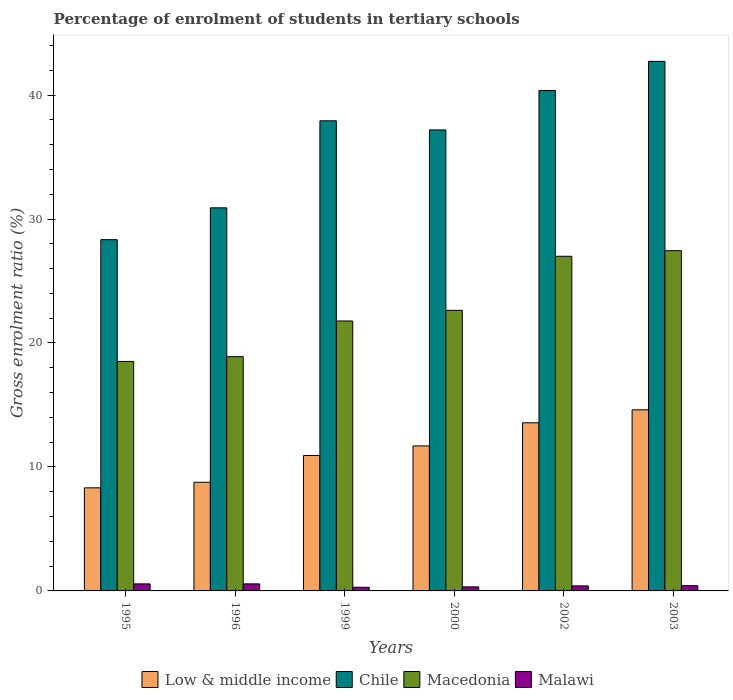Are the number of bars per tick equal to the number of legend labels?
Offer a terse response. Yes. Are the number of bars on each tick of the X-axis equal?
Your answer should be compact. Yes. How many bars are there on the 6th tick from the left?
Keep it short and to the point. 4. What is the label of the 1st group of bars from the left?
Keep it short and to the point. 1995. In how many cases, is the number of bars for a given year not equal to the number of legend labels?
Provide a short and direct response. 0. What is the percentage of students enrolled in tertiary schools in Macedonia in 1995?
Offer a very short reply. 18.51. Across all years, what is the maximum percentage of students enrolled in tertiary schools in Macedonia?
Your response must be concise. 27.44. Across all years, what is the minimum percentage of students enrolled in tertiary schools in Chile?
Offer a terse response. 28.33. In which year was the percentage of students enrolled in tertiary schools in Malawi maximum?
Keep it short and to the point. 1996. What is the total percentage of students enrolled in tertiary schools in Low & middle income in the graph?
Your answer should be compact. 67.87. What is the difference between the percentage of students enrolled in tertiary schools in Macedonia in 2000 and that in 2003?
Give a very brief answer. -4.81. What is the difference between the percentage of students enrolled in tertiary schools in Macedonia in 2003 and the percentage of students enrolled in tertiary schools in Malawi in 1995?
Keep it short and to the point. 26.88. What is the average percentage of students enrolled in tertiary schools in Macedonia per year?
Your response must be concise. 22.71. In the year 2003, what is the difference between the percentage of students enrolled in tertiary schools in Macedonia and percentage of students enrolled in tertiary schools in Malawi?
Your answer should be very brief. 27.02. What is the ratio of the percentage of students enrolled in tertiary schools in Malawi in 1999 to that in 2002?
Ensure brevity in your answer.  0.73. Is the percentage of students enrolled in tertiary schools in Chile in 1996 less than that in 2003?
Ensure brevity in your answer.  Yes. What is the difference between the highest and the second highest percentage of students enrolled in tertiary schools in Macedonia?
Provide a succinct answer. 0.45. What is the difference between the highest and the lowest percentage of students enrolled in tertiary schools in Chile?
Provide a succinct answer. 14.38. Is the sum of the percentage of students enrolled in tertiary schools in Macedonia in 1995 and 2003 greater than the maximum percentage of students enrolled in tertiary schools in Chile across all years?
Your response must be concise. Yes. What does the 3rd bar from the right in 1996 represents?
Your response must be concise. Chile. How many bars are there?
Offer a terse response. 24. How many years are there in the graph?
Make the answer very short. 6. What is the difference between two consecutive major ticks on the Y-axis?
Keep it short and to the point. 10. Does the graph contain any zero values?
Keep it short and to the point. No. How many legend labels are there?
Keep it short and to the point. 4. What is the title of the graph?
Your response must be concise. Percentage of enrolment of students in tertiary schools. What is the label or title of the X-axis?
Provide a short and direct response. Years. What is the label or title of the Y-axis?
Provide a short and direct response. Gross enrolment ratio (%). What is the Gross enrolment ratio (%) in Low & middle income in 1995?
Ensure brevity in your answer.  8.32. What is the Gross enrolment ratio (%) of Chile in 1995?
Your answer should be very brief. 28.33. What is the Gross enrolment ratio (%) in Macedonia in 1995?
Make the answer very short. 18.51. What is the Gross enrolment ratio (%) in Malawi in 1995?
Keep it short and to the point. 0.57. What is the Gross enrolment ratio (%) of Low & middle income in 1996?
Make the answer very short. 8.76. What is the Gross enrolment ratio (%) of Chile in 1996?
Your answer should be compact. 30.9. What is the Gross enrolment ratio (%) of Macedonia in 1996?
Ensure brevity in your answer.  18.9. What is the Gross enrolment ratio (%) of Malawi in 1996?
Your answer should be compact. 0.57. What is the Gross enrolment ratio (%) of Low & middle income in 1999?
Offer a terse response. 10.92. What is the Gross enrolment ratio (%) of Chile in 1999?
Offer a terse response. 37.92. What is the Gross enrolment ratio (%) of Macedonia in 1999?
Provide a short and direct response. 21.77. What is the Gross enrolment ratio (%) in Malawi in 1999?
Provide a succinct answer. 0.3. What is the Gross enrolment ratio (%) of Low & middle income in 2000?
Give a very brief answer. 11.7. What is the Gross enrolment ratio (%) of Chile in 2000?
Your answer should be very brief. 37.19. What is the Gross enrolment ratio (%) of Macedonia in 2000?
Your answer should be compact. 22.63. What is the Gross enrolment ratio (%) in Malawi in 2000?
Offer a terse response. 0.33. What is the Gross enrolment ratio (%) in Low & middle income in 2002?
Ensure brevity in your answer.  13.56. What is the Gross enrolment ratio (%) in Chile in 2002?
Ensure brevity in your answer.  40.37. What is the Gross enrolment ratio (%) in Macedonia in 2002?
Your answer should be compact. 26.99. What is the Gross enrolment ratio (%) in Malawi in 2002?
Your answer should be very brief. 0.41. What is the Gross enrolment ratio (%) in Low & middle income in 2003?
Keep it short and to the point. 14.61. What is the Gross enrolment ratio (%) in Chile in 2003?
Your response must be concise. 42.72. What is the Gross enrolment ratio (%) of Macedonia in 2003?
Provide a short and direct response. 27.44. What is the Gross enrolment ratio (%) in Malawi in 2003?
Keep it short and to the point. 0.42. Across all years, what is the maximum Gross enrolment ratio (%) in Low & middle income?
Offer a terse response. 14.61. Across all years, what is the maximum Gross enrolment ratio (%) in Chile?
Your response must be concise. 42.72. Across all years, what is the maximum Gross enrolment ratio (%) of Macedonia?
Your answer should be very brief. 27.44. Across all years, what is the maximum Gross enrolment ratio (%) of Malawi?
Your answer should be very brief. 0.57. Across all years, what is the minimum Gross enrolment ratio (%) in Low & middle income?
Make the answer very short. 8.32. Across all years, what is the minimum Gross enrolment ratio (%) of Chile?
Provide a short and direct response. 28.33. Across all years, what is the minimum Gross enrolment ratio (%) in Macedonia?
Ensure brevity in your answer.  18.51. Across all years, what is the minimum Gross enrolment ratio (%) in Malawi?
Your answer should be very brief. 0.3. What is the total Gross enrolment ratio (%) in Low & middle income in the graph?
Offer a very short reply. 67.87. What is the total Gross enrolment ratio (%) in Chile in the graph?
Provide a succinct answer. 217.43. What is the total Gross enrolment ratio (%) in Macedonia in the graph?
Your answer should be very brief. 136.25. What is the total Gross enrolment ratio (%) of Malawi in the graph?
Your answer should be very brief. 2.59. What is the difference between the Gross enrolment ratio (%) of Low & middle income in 1995 and that in 1996?
Offer a terse response. -0.45. What is the difference between the Gross enrolment ratio (%) of Chile in 1995 and that in 1996?
Provide a short and direct response. -2.57. What is the difference between the Gross enrolment ratio (%) in Macedonia in 1995 and that in 1996?
Provide a succinct answer. -0.39. What is the difference between the Gross enrolment ratio (%) of Malawi in 1995 and that in 1996?
Make the answer very short. -0. What is the difference between the Gross enrolment ratio (%) in Low & middle income in 1995 and that in 1999?
Ensure brevity in your answer.  -2.61. What is the difference between the Gross enrolment ratio (%) in Chile in 1995 and that in 1999?
Your response must be concise. -9.59. What is the difference between the Gross enrolment ratio (%) of Macedonia in 1995 and that in 1999?
Give a very brief answer. -3.26. What is the difference between the Gross enrolment ratio (%) of Malawi in 1995 and that in 1999?
Offer a terse response. 0.27. What is the difference between the Gross enrolment ratio (%) of Low & middle income in 1995 and that in 2000?
Your answer should be very brief. -3.38. What is the difference between the Gross enrolment ratio (%) of Chile in 1995 and that in 2000?
Ensure brevity in your answer.  -8.85. What is the difference between the Gross enrolment ratio (%) in Macedonia in 1995 and that in 2000?
Offer a terse response. -4.12. What is the difference between the Gross enrolment ratio (%) in Malawi in 1995 and that in 2000?
Give a very brief answer. 0.24. What is the difference between the Gross enrolment ratio (%) of Low & middle income in 1995 and that in 2002?
Offer a very short reply. -5.25. What is the difference between the Gross enrolment ratio (%) of Chile in 1995 and that in 2002?
Your response must be concise. -12.03. What is the difference between the Gross enrolment ratio (%) of Macedonia in 1995 and that in 2002?
Ensure brevity in your answer.  -8.48. What is the difference between the Gross enrolment ratio (%) of Malawi in 1995 and that in 2002?
Offer a very short reply. 0.16. What is the difference between the Gross enrolment ratio (%) in Low & middle income in 1995 and that in 2003?
Make the answer very short. -6.29. What is the difference between the Gross enrolment ratio (%) of Chile in 1995 and that in 2003?
Your answer should be very brief. -14.38. What is the difference between the Gross enrolment ratio (%) in Macedonia in 1995 and that in 2003?
Offer a terse response. -8.93. What is the difference between the Gross enrolment ratio (%) of Malawi in 1995 and that in 2003?
Offer a terse response. 0.14. What is the difference between the Gross enrolment ratio (%) of Low & middle income in 1996 and that in 1999?
Your answer should be very brief. -2.16. What is the difference between the Gross enrolment ratio (%) of Chile in 1996 and that in 1999?
Offer a terse response. -7.02. What is the difference between the Gross enrolment ratio (%) of Macedonia in 1996 and that in 1999?
Ensure brevity in your answer.  -2.88. What is the difference between the Gross enrolment ratio (%) in Malawi in 1996 and that in 1999?
Make the answer very short. 0.27. What is the difference between the Gross enrolment ratio (%) of Low & middle income in 1996 and that in 2000?
Your answer should be compact. -2.93. What is the difference between the Gross enrolment ratio (%) of Chile in 1996 and that in 2000?
Offer a terse response. -6.28. What is the difference between the Gross enrolment ratio (%) of Macedonia in 1996 and that in 2000?
Your answer should be very brief. -3.74. What is the difference between the Gross enrolment ratio (%) in Malawi in 1996 and that in 2000?
Provide a succinct answer. 0.24. What is the difference between the Gross enrolment ratio (%) of Low & middle income in 1996 and that in 2002?
Provide a short and direct response. -4.8. What is the difference between the Gross enrolment ratio (%) of Chile in 1996 and that in 2002?
Make the answer very short. -9.46. What is the difference between the Gross enrolment ratio (%) of Macedonia in 1996 and that in 2002?
Keep it short and to the point. -8.1. What is the difference between the Gross enrolment ratio (%) of Malawi in 1996 and that in 2002?
Give a very brief answer. 0.16. What is the difference between the Gross enrolment ratio (%) of Low & middle income in 1996 and that in 2003?
Your answer should be very brief. -5.84. What is the difference between the Gross enrolment ratio (%) in Chile in 1996 and that in 2003?
Ensure brevity in your answer.  -11.81. What is the difference between the Gross enrolment ratio (%) of Macedonia in 1996 and that in 2003?
Provide a succinct answer. -8.55. What is the difference between the Gross enrolment ratio (%) in Malawi in 1996 and that in 2003?
Give a very brief answer. 0.15. What is the difference between the Gross enrolment ratio (%) in Low & middle income in 1999 and that in 2000?
Make the answer very short. -0.77. What is the difference between the Gross enrolment ratio (%) of Chile in 1999 and that in 2000?
Provide a succinct answer. 0.74. What is the difference between the Gross enrolment ratio (%) of Macedonia in 1999 and that in 2000?
Your answer should be compact. -0.86. What is the difference between the Gross enrolment ratio (%) in Malawi in 1999 and that in 2000?
Your answer should be compact. -0.03. What is the difference between the Gross enrolment ratio (%) of Low & middle income in 1999 and that in 2002?
Make the answer very short. -2.64. What is the difference between the Gross enrolment ratio (%) of Chile in 1999 and that in 2002?
Ensure brevity in your answer.  -2.44. What is the difference between the Gross enrolment ratio (%) in Macedonia in 1999 and that in 2002?
Provide a short and direct response. -5.22. What is the difference between the Gross enrolment ratio (%) of Malawi in 1999 and that in 2002?
Give a very brief answer. -0.11. What is the difference between the Gross enrolment ratio (%) in Low & middle income in 1999 and that in 2003?
Keep it short and to the point. -3.68. What is the difference between the Gross enrolment ratio (%) in Chile in 1999 and that in 2003?
Offer a very short reply. -4.8. What is the difference between the Gross enrolment ratio (%) in Macedonia in 1999 and that in 2003?
Give a very brief answer. -5.67. What is the difference between the Gross enrolment ratio (%) in Malawi in 1999 and that in 2003?
Provide a short and direct response. -0.13. What is the difference between the Gross enrolment ratio (%) of Low & middle income in 2000 and that in 2002?
Your answer should be very brief. -1.87. What is the difference between the Gross enrolment ratio (%) in Chile in 2000 and that in 2002?
Provide a succinct answer. -3.18. What is the difference between the Gross enrolment ratio (%) of Macedonia in 2000 and that in 2002?
Keep it short and to the point. -4.36. What is the difference between the Gross enrolment ratio (%) of Malawi in 2000 and that in 2002?
Give a very brief answer. -0.08. What is the difference between the Gross enrolment ratio (%) in Low & middle income in 2000 and that in 2003?
Your answer should be compact. -2.91. What is the difference between the Gross enrolment ratio (%) of Chile in 2000 and that in 2003?
Ensure brevity in your answer.  -5.53. What is the difference between the Gross enrolment ratio (%) of Macedonia in 2000 and that in 2003?
Make the answer very short. -4.81. What is the difference between the Gross enrolment ratio (%) in Malawi in 2000 and that in 2003?
Your answer should be very brief. -0.1. What is the difference between the Gross enrolment ratio (%) of Low & middle income in 2002 and that in 2003?
Your response must be concise. -1.04. What is the difference between the Gross enrolment ratio (%) of Chile in 2002 and that in 2003?
Keep it short and to the point. -2.35. What is the difference between the Gross enrolment ratio (%) of Macedonia in 2002 and that in 2003?
Your response must be concise. -0.45. What is the difference between the Gross enrolment ratio (%) of Malawi in 2002 and that in 2003?
Ensure brevity in your answer.  -0.02. What is the difference between the Gross enrolment ratio (%) of Low & middle income in 1995 and the Gross enrolment ratio (%) of Chile in 1996?
Offer a terse response. -22.59. What is the difference between the Gross enrolment ratio (%) in Low & middle income in 1995 and the Gross enrolment ratio (%) in Macedonia in 1996?
Provide a succinct answer. -10.58. What is the difference between the Gross enrolment ratio (%) in Low & middle income in 1995 and the Gross enrolment ratio (%) in Malawi in 1996?
Provide a succinct answer. 7.75. What is the difference between the Gross enrolment ratio (%) in Chile in 1995 and the Gross enrolment ratio (%) in Macedonia in 1996?
Your answer should be very brief. 9.44. What is the difference between the Gross enrolment ratio (%) of Chile in 1995 and the Gross enrolment ratio (%) of Malawi in 1996?
Your response must be concise. 27.77. What is the difference between the Gross enrolment ratio (%) of Macedonia in 1995 and the Gross enrolment ratio (%) of Malawi in 1996?
Provide a succinct answer. 17.94. What is the difference between the Gross enrolment ratio (%) of Low & middle income in 1995 and the Gross enrolment ratio (%) of Chile in 1999?
Give a very brief answer. -29.61. What is the difference between the Gross enrolment ratio (%) of Low & middle income in 1995 and the Gross enrolment ratio (%) of Macedonia in 1999?
Ensure brevity in your answer.  -13.46. What is the difference between the Gross enrolment ratio (%) of Low & middle income in 1995 and the Gross enrolment ratio (%) of Malawi in 1999?
Ensure brevity in your answer.  8.02. What is the difference between the Gross enrolment ratio (%) in Chile in 1995 and the Gross enrolment ratio (%) in Macedonia in 1999?
Offer a terse response. 6.56. What is the difference between the Gross enrolment ratio (%) in Chile in 1995 and the Gross enrolment ratio (%) in Malawi in 1999?
Give a very brief answer. 28.04. What is the difference between the Gross enrolment ratio (%) of Macedonia in 1995 and the Gross enrolment ratio (%) of Malawi in 1999?
Provide a short and direct response. 18.21. What is the difference between the Gross enrolment ratio (%) of Low & middle income in 1995 and the Gross enrolment ratio (%) of Chile in 2000?
Offer a very short reply. -28.87. What is the difference between the Gross enrolment ratio (%) in Low & middle income in 1995 and the Gross enrolment ratio (%) in Macedonia in 2000?
Your response must be concise. -14.32. What is the difference between the Gross enrolment ratio (%) of Low & middle income in 1995 and the Gross enrolment ratio (%) of Malawi in 2000?
Make the answer very short. 7.99. What is the difference between the Gross enrolment ratio (%) of Chile in 1995 and the Gross enrolment ratio (%) of Macedonia in 2000?
Offer a terse response. 5.7. What is the difference between the Gross enrolment ratio (%) of Chile in 1995 and the Gross enrolment ratio (%) of Malawi in 2000?
Offer a terse response. 28.01. What is the difference between the Gross enrolment ratio (%) in Macedonia in 1995 and the Gross enrolment ratio (%) in Malawi in 2000?
Provide a succinct answer. 18.18. What is the difference between the Gross enrolment ratio (%) of Low & middle income in 1995 and the Gross enrolment ratio (%) of Chile in 2002?
Provide a short and direct response. -32.05. What is the difference between the Gross enrolment ratio (%) of Low & middle income in 1995 and the Gross enrolment ratio (%) of Macedonia in 2002?
Give a very brief answer. -18.68. What is the difference between the Gross enrolment ratio (%) of Low & middle income in 1995 and the Gross enrolment ratio (%) of Malawi in 2002?
Your answer should be compact. 7.91. What is the difference between the Gross enrolment ratio (%) of Chile in 1995 and the Gross enrolment ratio (%) of Macedonia in 2002?
Ensure brevity in your answer.  1.34. What is the difference between the Gross enrolment ratio (%) of Chile in 1995 and the Gross enrolment ratio (%) of Malawi in 2002?
Ensure brevity in your answer.  27.93. What is the difference between the Gross enrolment ratio (%) of Macedonia in 1995 and the Gross enrolment ratio (%) of Malawi in 2002?
Your answer should be very brief. 18.1. What is the difference between the Gross enrolment ratio (%) of Low & middle income in 1995 and the Gross enrolment ratio (%) of Chile in 2003?
Your answer should be very brief. -34.4. What is the difference between the Gross enrolment ratio (%) of Low & middle income in 1995 and the Gross enrolment ratio (%) of Macedonia in 2003?
Provide a short and direct response. -19.13. What is the difference between the Gross enrolment ratio (%) of Low & middle income in 1995 and the Gross enrolment ratio (%) of Malawi in 2003?
Keep it short and to the point. 7.89. What is the difference between the Gross enrolment ratio (%) in Chile in 1995 and the Gross enrolment ratio (%) in Macedonia in 2003?
Give a very brief answer. 0.89. What is the difference between the Gross enrolment ratio (%) in Chile in 1995 and the Gross enrolment ratio (%) in Malawi in 2003?
Offer a very short reply. 27.91. What is the difference between the Gross enrolment ratio (%) of Macedonia in 1995 and the Gross enrolment ratio (%) of Malawi in 2003?
Your answer should be very brief. 18.09. What is the difference between the Gross enrolment ratio (%) of Low & middle income in 1996 and the Gross enrolment ratio (%) of Chile in 1999?
Provide a succinct answer. -29.16. What is the difference between the Gross enrolment ratio (%) of Low & middle income in 1996 and the Gross enrolment ratio (%) of Macedonia in 1999?
Offer a very short reply. -13.01. What is the difference between the Gross enrolment ratio (%) in Low & middle income in 1996 and the Gross enrolment ratio (%) in Malawi in 1999?
Your answer should be very brief. 8.47. What is the difference between the Gross enrolment ratio (%) of Chile in 1996 and the Gross enrolment ratio (%) of Macedonia in 1999?
Make the answer very short. 9.13. What is the difference between the Gross enrolment ratio (%) of Chile in 1996 and the Gross enrolment ratio (%) of Malawi in 1999?
Offer a very short reply. 30.61. What is the difference between the Gross enrolment ratio (%) in Macedonia in 1996 and the Gross enrolment ratio (%) in Malawi in 1999?
Provide a short and direct response. 18.6. What is the difference between the Gross enrolment ratio (%) in Low & middle income in 1996 and the Gross enrolment ratio (%) in Chile in 2000?
Offer a very short reply. -28.42. What is the difference between the Gross enrolment ratio (%) in Low & middle income in 1996 and the Gross enrolment ratio (%) in Macedonia in 2000?
Provide a short and direct response. -13.87. What is the difference between the Gross enrolment ratio (%) of Low & middle income in 1996 and the Gross enrolment ratio (%) of Malawi in 2000?
Keep it short and to the point. 8.44. What is the difference between the Gross enrolment ratio (%) of Chile in 1996 and the Gross enrolment ratio (%) of Macedonia in 2000?
Make the answer very short. 8.27. What is the difference between the Gross enrolment ratio (%) of Chile in 1996 and the Gross enrolment ratio (%) of Malawi in 2000?
Your response must be concise. 30.58. What is the difference between the Gross enrolment ratio (%) of Macedonia in 1996 and the Gross enrolment ratio (%) of Malawi in 2000?
Your answer should be very brief. 18.57. What is the difference between the Gross enrolment ratio (%) of Low & middle income in 1996 and the Gross enrolment ratio (%) of Chile in 2002?
Offer a terse response. -31.6. What is the difference between the Gross enrolment ratio (%) of Low & middle income in 1996 and the Gross enrolment ratio (%) of Macedonia in 2002?
Make the answer very short. -18.23. What is the difference between the Gross enrolment ratio (%) in Low & middle income in 1996 and the Gross enrolment ratio (%) in Malawi in 2002?
Provide a short and direct response. 8.36. What is the difference between the Gross enrolment ratio (%) of Chile in 1996 and the Gross enrolment ratio (%) of Macedonia in 2002?
Ensure brevity in your answer.  3.91. What is the difference between the Gross enrolment ratio (%) in Chile in 1996 and the Gross enrolment ratio (%) in Malawi in 2002?
Your answer should be compact. 30.5. What is the difference between the Gross enrolment ratio (%) of Macedonia in 1996 and the Gross enrolment ratio (%) of Malawi in 2002?
Offer a terse response. 18.49. What is the difference between the Gross enrolment ratio (%) in Low & middle income in 1996 and the Gross enrolment ratio (%) in Chile in 2003?
Offer a very short reply. -33.95. What is the difference between the Gross enrolment ratio (%) of Low & middle income in 1996 and the Gross enrolment ratio (%) of Macedonia in 2003?
Provide a short and direct response. -18.68. What is the difference between the Gross enrolment ratio (%) in Low & middle income in 1996 and the Gross enrolment ratio (%) in Malawi in 2003?
Ensure brevity in your answer.  8.34. What is the difference between the Gross enrolment ratio (%) of Chile in 1996 and the Gross enrolment ratio (%) of Macedonia in 2003?
Make the answer very short. 3.46. What is the difference between the Gross enrolment ratio (%) of Chile in 1996 and the Gross enrolment ratio (%) of Malawi in 2003?
Provide a succinct answer. 30.48. What is the difference between the Gross enrolment ratio (%) in Macedonia in 1996 and the Gross enrolment ratio (%) in Malawi in 2003?
Your answer should be compact. 18.47. What is the difference between the Gross enrolment ratio (%) in Low & middle income in 1999 and the Gross enrolment ratio (%) in Chile in 2000?
Offer a terse response. -26.26. What is the difference between the Gross enrolment ratio (%) in Low & middle income in 1999 and the Gross enrolment ratio (%) in Macedonia in 2000?
Provide a succinct answer. -11.71. What is the difference between the Gross enrolment ratio (%) of Low & middle income in 1999 and the Gross enrolment ratio (%) of Malawi in 2000?
Offer a very short reply. 10.6. What is the difference between the Gross enrolment ratio (%) in Chile in 1999 and the Gross enrolment ratio (%) in Macedonia in 2000?
Offer a very short reply. 15.29. What is the difference between the Gross enrolment ratio (%) in Chile in 1999 and the Gross enrolment ratio (%) in Malawi in 2000?
Offer a terse response. 37.6. What is the difference between the Gross enrolment ratio (%) in Macedonia in 1999 and the Gross enrolment ratio (%) in Malawi in 2000?
Your answer should be compact. 21.45. What is the difference between the Gross enrolment ratio (%) of Low & middle income in 1999 and the Gross enrolment ratio (%) of Chile in 2002?
Your response must be concise. -29.44. What is the difference between the Gross enrolment ratio (%) of Low & middle income in 1999 and the Gross enrolment ratio (%) of Macedonia in 2002?
Provide a succinct answer. -16.07. What is the difference between the Gross enrolment ratio (%) in Low & middle income in 1999 and the Gross enrolment ratio (%) in Malawi in 2002?
Offer a very short reply. 10.52. What is the difference between the Gross enrolment ratio (%) in Chile in 1999 and the Gross enrolment ratio (%) in Macedonia in 2002?
Ensure brevity in your answer.  10.93. What is the difference between the Gross enrolment ratio (%) of Chile in 1999 and the Gross enrolment ratio (%) of Malawi in 2002?
Keep it short and to the point. 37.52. What is the difference between the Gross enrolment ratio (%) in Macedonia in 1999 and the Gross enrolment ratio (%) in Malawi in 2002?
Your answer should be compact. 21.37. What is the difference between the Gross enrolment ratio (%) of Low & middle income in 1999 and the Gross enrolment ratio (%) of Chile in 2003?
Keep it short and to the point. -31.79. What is the difference between the Gross enrolment ratio (%) of Low & middle income in 1999 and the Gross enrolment ratio (%) of Macedonia in 2003?
Provide a short and direct response. -16.52. What is the difference between the Gross enrolment ratio (%) of Low & middle income in 1999 and the Gross enrolment ratio (%) of Malawi in 2003?
Offer a terse response. 10.5. What is the difference between the Gross enrolment ratio (%) of Chile in 1999 and the Gross enrolment ratio (%) of Macedonia in 2003?
Provide a succinct answer. 10.48. What is the difference between the Gross enrolment ratio (%) in Chile in 1999 and the Gross enrolment ratio (%) in Malawi in 2003?
Offer a very short reply. 37.5. What is the difference between the Gross enrolment ratio (%) of Macedonia in 1999 and the Gross enrolment ratio (%) of Malawi in 2003?
Keep it short and to the point. 21.35. What is the difference between the Gross enrolment ratio (%) of Low & middle income in 2000 and the Gross enrolment ratio (%) of Chile in 2002?
Your answer should be very brief. -28.67. What is the difference between the Gross enrolment ratio (%) of Low & middle income in 2000 and the Gross enrolment ratio (%) of Macedonia in 2002?
Provide a succinct answer. -15.3. What is the difference between the Gross enrolment ratio (%) in Low & middle income in 2000 and the Gross enrolment ratio (%) in Malawi in 2002?
Offer a very short reply. 11.29. What is the difference between the Gross enrolment ratio (%) of Chile in 2000 and the Gross enrolment ratio (%) of Macedonia in 2002?
Keep it short and to the point. 10.19. What is the difference between the Gross enrolment ratio (%) in Chile in 2000 and the Gross enrolment ratio (%) in Malawi in 2002?
Ensure brevity in your answer.  36.78. What is the difference between the Gross enrolment ratio (%) in Macedonia in 2000 and the Gross enrolment ratio (%) in Malawi in 2002?
Ensure brevity in your answer.  22.23. What is the difference between the Gross enrolment ratio (%) in Low & middle income in 2000 and the Gross enrolment ratio (%) in Chile in 2003?
Your answer should be compact. -31.02. What is the difference between the Gross enrolment ratio (%) in Low & middle income in 2000 and the Gross enrolment ratio (%) in Macedonia in 2003?
Provide a succinct answer. -15.75. What is the difference between the Gross enrolment ratio (%) in Low & middle income in 2000 and the Gross enrolment ratio (%) in Malawi in 2003?
Provide a short and direct response. 11.27. What is the difference between the Gross enrolment ratio (%) in Chile in 2000 and the Gross enrolment ratio (%) in Macedonia in 2003?
Provide a succinct answer. 9.74. What is the difference between the Gross enrolment ratio (%) in Chile in 2000 and the Gross enrolment ratio (%) in Malawi in 2003?
Offer a terse response. 36.76. What is the difference between the Gross enrolment ratio (%) in Macedonia in 2000 and the Gross enrolment ratio (%) in Malawi in 2003?
Offer a terse response. 22.21. What is the difference between the Gross enrolment ratio (%) in Low & middle income in 2002 and the Gross enrolment ratio (%) in Chile in 2003?
Your response must be concise. -29.15. What is the difference between the Gross enrolment ratio (%) of Low & middle income in 2002 and the Gross enrolment ratio (%) of Macedonia in 2003?
Your answer should be compact. -13.88. What is the difference between the Gross enrolment ratio (%) in Low & middle income in 2002 and the Gross enrolment ratio (%) in Malawi in 2003?
Keep it short and to the point. 13.14. What is the difference between the Gross enrolment ratio (%) of Chile in 2002 and the Gross enrolment ratio (%) of Macedonia in 2003?
Keep it short and to the point. 12.92. What is the difference between the Gross enrolment ratio (%) of Chile in 2002 and the Gross enrolment ratio (%) of Malawi in 2003?
Keep it short and to the point. 39.94. What is the difference between the Gross enrolment ratio (%) in Macedonia in 2002 and the Gross enrolment ratio (%) in Malawi in 2003?
Keep it short and to the point. 26.57. What is the average Gross enrolment ratio (%) in Low & middle income per year?
Give a very brief answer. 11.31. What is the average Gross enrolment ratio (%) in Chile per year?
Your answer should be very brief. 36.24. What is the average Gross enrolment ratio (%) in Macedonia per year?
Ensure brevity in your answer.  22.71. What is the average Gross enrolment ratio (%) in Malawi per year?
Your response must be concise. 0.43. In the year 1995, what is the difference between the Gross enrolment ratio (%) in Low & middle income and Gross enrolment ratio (%) in Chile?
Your answer should be compact. -20.02. In the year 1995, what is the difference between the Gross enrolment ratio (%) of Low & middle income and Gross enrolment ratio (%) of Macedonia?
Your answer should be compact. -10.19. In the year 1995, what is the difference between the Gross enrolment ratio (%) of Low & middle income and Gross enrolment ratio (%) of Malawi?
Keep it short and to the point. 7.75. In the year 1995, what is the difference between the Gross enrolment ratio (%) in Chile and Gross enrolment ratio (%) in Macedonia?
Offer a terse response. 9.82. In the year 1995, what is the difference between the Gross enrolment ratio (%) of Chile and Gross enrolment ratio (%) of Malawi?
Ensure brevity in your answer.  27.77. In the year 1995, what is the difference between the Gross enrolment ratio (%) of Macedonia and Gross enrolment ratio (%) of Malawi?
Provide a short and direct response. 17.94. In the year 1996, what is the difference between the Gross enrolment ratio (%) of Low & middle income and Gross enrolment ratio (%) of Chile?
Offer a very short reply. -22.14. In the year 1996, what is the difference between the Gross enrolment ratio (%) in Low & middle income and Gross enrolment ratio (%) in Macedonia?
Give a very brief answer. -10.13. In the year 1996, what is the difference between the Gross enrolment ratio (%) in Low & middle income and Gross enrolment ratio (%) in Malawi?
Offer a very short reply. 8.2. In the year 1996, what is the difference between the Gross enrolment ratio (%) of Chile and Gross enrolment ratio (%) of Macedonia?
Your response must be concise. 12.01. In the year 1996, what is the difference between the Gross enrolment ratio (%) of Chile and Gross enrolment ratio (%) of Malawi?
Your answer should be very brief. 30.33. In the year 1996, what is the difference between the Gross enrolment ratio (%) in Macedonia and Gross enrolment ratio (%) in Malawi?
Offer a very short reply. 18.33. In the year 1999, what is the difference between the Gross enrolment ratio (%) of Low & middle income and Gross enrolment ratio (%) of Chile?
Make the answer very short. -27. In the year 1999, what is the difference between the Gross enrolment ratio (%) in Low & middle income and Gross enrolment ratio (%) in Macedonia?
Give a very brief answer. -10.85. In the year 1999, what is the difference between the Gross enrolment ratio (%) of Low & middle income and Gross enrolment ratio (%) of Malawi?
Give a very brief answer. 10.63. In the year 1999, what is the difference between the Gross enrolment ratio (%) in Chile and Gross enrolment ratio (%) in Macedonia?
Provide a succinct answer. 16.15. In the year 1999, what is the difference between the Gross enrolment ratio (%) of Chile and Gross enrolment ratio (%) of Malawi?
Keep it short and to the point. 37.63. In the year 1999, what is the difference between the Gross enrolment ratio (%) in Macedonia and Gross enrolment ratio (%) in Malawi?
Your response must be concise. 21.48. In the year 2000, what is the difference between the Gross enrolment ratio (%) of Low & middle income and Gross enrolment ratio (%) of Chile?
Keep it short and to the point. -25.49. In the year 2000, what is the difference between the Gross enrolment ratio (%) of Low & middle income and Gross enrolment ratio (%) of Macedonia?
Your answer should be compact. -10.94. In the year 2000, what is the difference between the Gross enrolment ratio (%) in Low & middle income and Gross enrolment ratio (%) in Malawi?
Make the answer very short. 11.37. In the year 2000, what is the difference between the Gross enrolment ratio (%) of Chile and Gross enrolment ratio (%) of Macedonia?
Make the answer very short. 14.55. In the year 2000, what is the difference between the Gross enrolment ratio (%) in Chile and Gross enrolment ratio (%) in Malawi?
Make the answer very short. 36.86. In the year 2000, what is the difference between the Gross enrolment ratio (%) of Macedonia and Gross enrolment ratio (%) of Malawi?
Provide a succinct answer. 22.31. In the year 2002, what is the difference between the Gross enrolment ratio (%) in Low & middle income and Gross enrolment ratio (%) in Chile?
Offer a very short reply. -26.8. In the year 2002, what is the difference between the Gross enrolment ratio (%) of Low & middle income and Gross enrolment ratio (%) of Macedonia?
Your response must be concise. -13.43. In the year 2002, what is the difference between the Gross enrolment ratio (%) of Low & middle income and Gross enrolment ratio (%) of Malawi?
Keep it short and to the point. 13.16. In the year 2002, what is the difference between the Gross enrolment ratio (%) of Chile and Gross enrolment ratio (%) of Macedonia?
Your response must be concise. 13.37. In the year 2002, what is the difference between the Gross enrolment ratio (%) in Chile and Gross enrolment ratio (%) in Malawi?
Provide a succinct answer. 39.96. In the year 2002, what is the difference between the Gross enrolment ratio (%) in Macedonia and Gross enrolment ratio (%) in Malawi?
Offer a very short reply. 26.59. In the year 2003, what is the difference between the Gross enrolment ratio (%) of Low & middle income and Gross enrolment ratio (%) of Chile?
Give a very brief answer. -28.11. In the year 2003, what is the difference between the Gross enrolment ratio (%) in Low & middle income and Gross enrolment ratio (%) in Macedonia?
Your answer should be very brief. -12.84. In the year 2003, what is the difference between the Gross enrolment ratio (%) of Low & middle income and Gross enrolment ratio (%) of Malawi?
Give a very brief answer. 14.19. In the year 2003, what is the difference between the Gross enrolment ratio (%) of Chile and Gross enrolment ratio (%) of Macedonia?
Provide a succinct answer. 15.27. In the year 2003, what is the difference between the Gross enrolment ratio (%) in Chile and Gross enrolment ratio (%) in Malawi?
Give a very brief answer. 42.29. In the year 2003, what is the difference between the Gross enrolment ratio (%) in Macedonia and Gross enrolment ratio (%) in Malawi?
Keep it short and to the point. 27.02. What is the ratio of the Gross enrolment ratio (%) in Low & middle income in 1995 to that in 1996?
Your response must be concise. 0.95. What is the ratio of the Gross enrolment ratio (%) of Chile in 1995 to that in 1996?
Give a very brief answer. 0.92. What is the ratio of the Gross enrolment ratio (%) of Macedonia in 1995 to that in 1996?
Offer a terse response. 0.98. What is the ratio of the Gross enrolment ratio (%) in Low & middle income in 1995 to that in 1999?
Give a very brief answer. 0.76. What is the ratio of the Gross enrolment ratio (%) of Chile in 1995 to that in 1999?
Ensure brevity in your answer.  0.75. What is the ratio of the Gross enrolment ratio (%) in Macedonia in 1995 to that in 1999?
Provide a short and direct response. 0.85. What is the ratio of the Gross enrolment ratio (%) of Malawi in 1995 to that in 1999?
Provide a short and direct response. 1.92. What is the ratio of the Gross enrolment ratio (%) in Low & middle income in 1995 to that in 2000?
Provide a succinct answer. 0.71. What is the ratio of the Gross enrolment ratio (%) of Chile in 1995 to that in 2000?
Provide a short and direct response. 0.76. What is the ratio of the Gross enrolment ratio (%) of Macedonia in 1995 to that in 2000?
Your response must be concise. 0.82. What is the ratio of the Gross enrolment ratio (%) in Malawi in 1995 to that in 2000?
Your answer should be compact. 1.74. What is the ratio of the Gross enrolment ratio (%) in Low & middle income in 1995 to that in 2002?
Your answer should be compact. 0.61. What is the ratio of the Gross enrolment ratio (%) of Chile in 1995 to that in 2002?
Your response must be concise. 0.7. What is the ratio of the Gross enrolment ratio (%) in Macedonia in 1995 to that in 2002?
Make the answer very short. 0.69. What is the ratio of the Gross enrolment ratio (%) in Malawi in 1995 to that in 2002?
Offer a very short reply. 1.4. What is the ratio of the Gross enrolment ratio (%) in Low & middle income in 1995 to that in 2003?
Your answer should be compact. 0.57. What is the ratio of the Gross enrolment ratio (%) of Chile in 1995 to that in 2003?
Your response must be concise. 0.66. What is the ratio of the Gross enrolment ratio (%) of Macedonia in 1995 to that in 2003?
Offer a terse response. 0.67. What is the ratio of the Gross enrolment ratio (%) in Malawi in 1995 to that in 2003?
Give a very brief answer. 1.34. What is the ratio of the Gross enrolment ratio (%) of Low & middle income in 1996 to that in 1999?
Ensure brevity in your answer.  0.8. What is the ratio of the Gross enrolment ratio (%) of Chile in 1996 to that in 1999?
Your answer should be very brief. 0.81. What is the ratio of the Gross enrolment ratio (%) of Macedonia in 1996 to that in 1999?
Provide a short and direct response. 0.87. What is the ratio of the Gross enrolment ratio (%) in Malawi in 1996 to that in 1999?
Provide a succinct answer. 1.92. What is the ratio of the Gross enrolment ratio (%) in Low & middle income in 1996 to that in 2000?
Provide a short and direct response. 0.75. What is the ratio of the Gross enrolment ratio (%) of Chile in 1996 to that in 2000?
Ensure brevity in your answer.  0.83. What is the ratio of the Gross enrolment ratio (%) of Macedonia in 1996 to that in 2000?
Give a very brief answer. 0.83. What is the ratio of the Gross enrolment ratio (%) in Malawi in 1996 to that in 2000?
Provide a succinct answer. 1.74. What is the ratio of the Gross enrolment ratio (%) in Low & middle income in 1996 to that in 2002?
Give a very brief answer. 0.65. What is the ratio of the Gross enrolment ratio (%) in Chile in 1996 to that in 2002?
Give a very brief answer. 0.77. What is the ratio of the Gross enrolment ratio (%) of Malawi in 1996 to that in 2002?
Make the answer very short. 1.4. What is the ratio of the Gross enrolment ratio (%) of Low & middle income in 1996 to that in 2003?
Ensure brevity in your answer.  0.6. What is the ratio of the Gross enrolment ratio (%) of Chile in 1996 to that in 2003?
Keep it short and to the point. 0.72. What is the ratio of the Gross enrolment ratio (%) in Macedonia in 1996 to that in 2003?
Ensure brevity in your answer.  0.69. What is the ratio of the Gross enrolment ratio (%) of Malawi in 1996 to that in 2003?
Offer a very short reply. 1.34. What is the ratio of the Gross enrolment ratio (%) of Low & middle income in 1999 to that in 2000?
Your answer should be very brief. 0.93. What is the ratio of the Gross enrolment ratio (%) in Chile in 1999 to that in 2000?
Offer a very short reply. 1.02. What is the ratio of the Gross enrolment ratio (%) in Macedonia in 1999 to that in 2000?
Give a very brief answer. 0.96. What is the ratio of the Gross enrolment ratio (%) of Malawi in 1999 to that in 2000?
Your response must be concise. 0.91. What is the ratio of the Gross enrolment ratio (%) in Low & middle income in 1999 to that in 2002?
Give a very brief answer. 0.81. What is the ratio of the Gross enrolment ratio (%) of Chile in 1999 to that in 2002?
Keep it short and to the point. 0.94. What is the ratio of the Gross enrolment ratio (%) of Macedonia in 1999 to that in 2002?
Make the answer very short. 0.81. What is the ratio of the Gross enrolment ratio (%) in Malawi in 1999 to that in 2002?
Give a very brief answer. 0.73. What is the ratio of the Gross enrolment ratio (%) of Low & middle income in 1999 to that in 2003?
Provide a short and direct response. 0.75. What is the ratio of the Gross enrolment ratio (%) of Chile in 1999 to that in 2003?
Keep it short and to the point. 0.89. What is the ratio of the Gross enrolment ratio (%) in Macedonia in 1999 to that in 2003?
Provide a short and direct response. 0.79. What is the ratio of the Gross enrolment ratio (%) in Malawi in 1999 to that in 2003?
Provide a short and direct response. 0.7. What is the ratio of the Gross enrolment ratio (%) of Low & middle income in 2000 to that in 2002?
Keep it short and to the point. 0.86. What is the ratio of the Gross enrolment ratio (%) in Chile in 2000 to that in 2002?
Provide a succinct answer. 0.92. What is the ratio of the Gross enrolment ratio (%) of Macedonia in 2000 to that in 2002?
Offer a terse response. 0.84. What is the ratio of the Gross enrolment ratio (%) of Malawi in 2000 to that in 2002?
Your answer should be compact. 0.8. What is the ratio of the Gross enrolment ratio (%) of Low & middle income in 2000 to that in 2003?
Your answer should be very brief. 0.8. What is the ratio of the Gross enrolment ratio (%) in Chile in 2000 to that in 2003?
Make the answer very short. 0.87. What is the ratio of the Gross enrolment ratio (%) in Macedonia in 2000 to that in 2003?
Your response must be concise. 0.82. What is the ratio of the Gross enrolment ratio (%) of Malawi in 2000 to that in 2003?
Keep it short and to the point. 0.77. What is the ratio of the Gross enrolment ratio (%) in Low & middle income in 2002 to that in 2003?
Ensure brevity in your answer.  0.93. What is the ratio of the Gross enrolment ratio (%) of Chile in 2002 to that in 2003?
Keep it short and to the point. 0.94. What is the ratio of the Gross enrolment ratio (%) of Macedonia in 2002 to that in 2003?
Your answer should be very brief. 0.98. What is the ratio of the Gross enrolment ratio (%) of Malawi in 2002 to that in 2003?
Provide a succinct answer. 0.96. What is the difference between the highest and the second highest Gross enrolment ratio (%) in Low & middle income?
Your answer should be very brief. 1.04. What is the difference between the highest and the second highest Gross enrolment ratio (%) of Chile?
Your response must be concise. 2.35. What is the difference between the highest and the second highest Gross enrolment ratio (%) of Macedonia?
Offer a terse response. 0.45. What is the difference between the highest and the lowest Gross enrolment ratio (%) of Low & middle income?
Give a very brief answer. 6.29. What is the difference between the highest and the lowest Gross enrolment ratio (%) in Chile?
Make the answer very short. 14.38. What is the difference between the highest and the lowest Gross enrolment ratio (%) of Macedonia?
Offer a very short reply. 8.93. What is the difference between the highest and the lowest Gross enrolment ratio (%) of Malawi?
Your response must be concise. 0.27. 